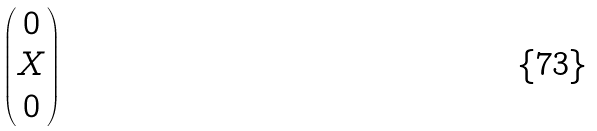<formula> <loc_0><loc_0><loc_500><loc_500>\begin{pmatrix} 0 \\ X \\ 0 \\ \end{pmatrix}</formula> 